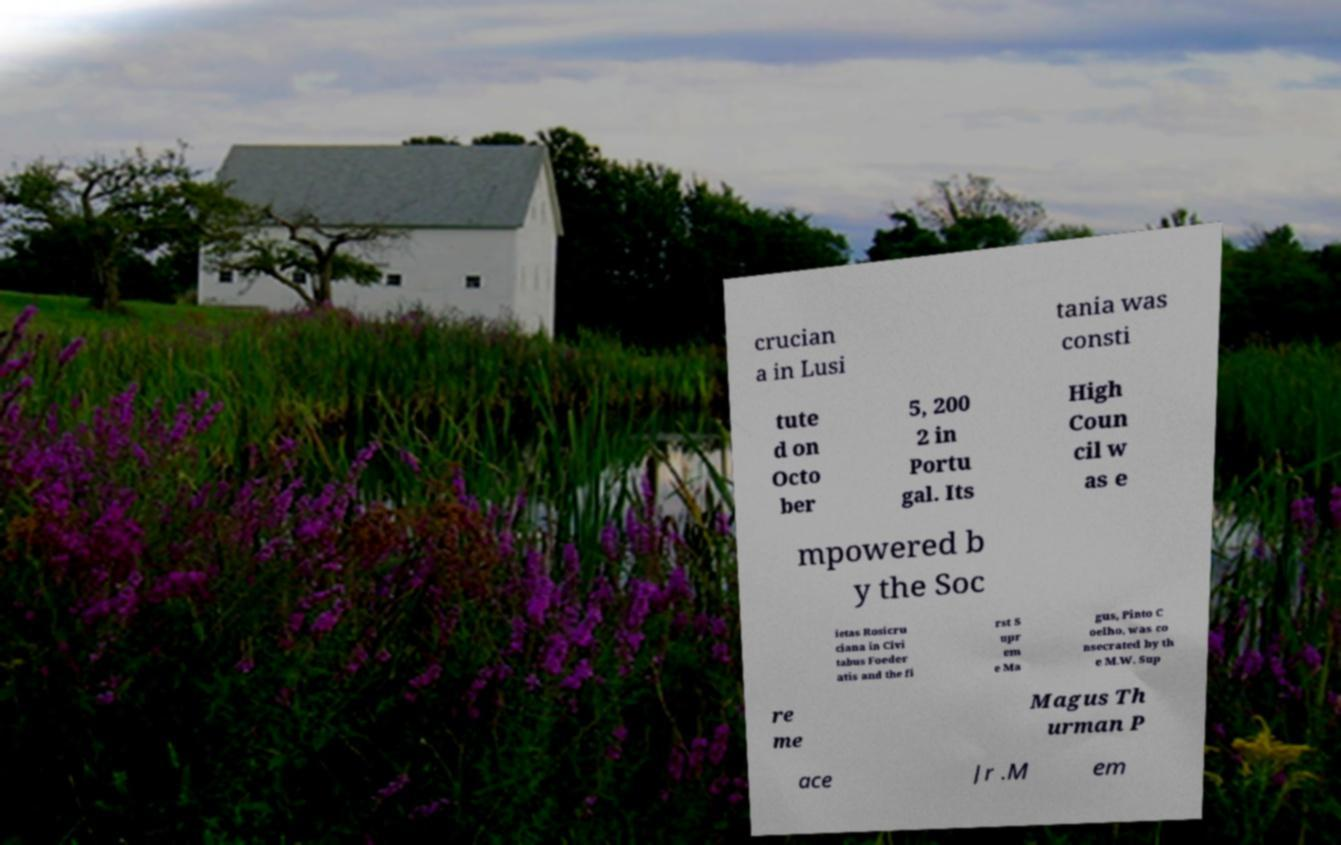There's text embedded in this image that I need extracted. Can you transcribe it verbatim? crucian a in Lusi tania was consti tute d on Octo ber 5, 200 2 in Portu gal. Its High Coun cil w as e mpowered b y the Soc ietas Rosicru ciana in Civi tabus Foeder atis and the fi rst S upr em e Ma gus, Pinto C oelho, was co nsecrated by th e M.W. Sup re me Magus Th urman P ace Jr .M em 